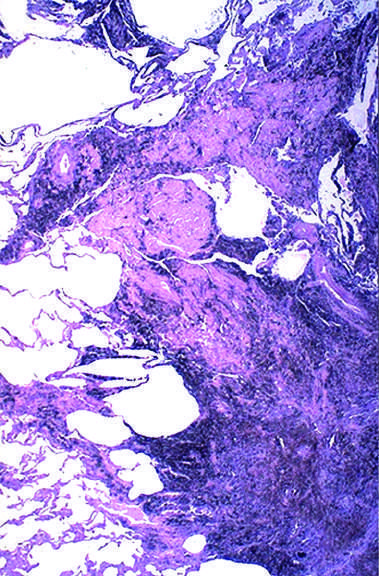what is a large amount of black pigment associated with?
Answer the question using a single word or phrase. Fibrosis 